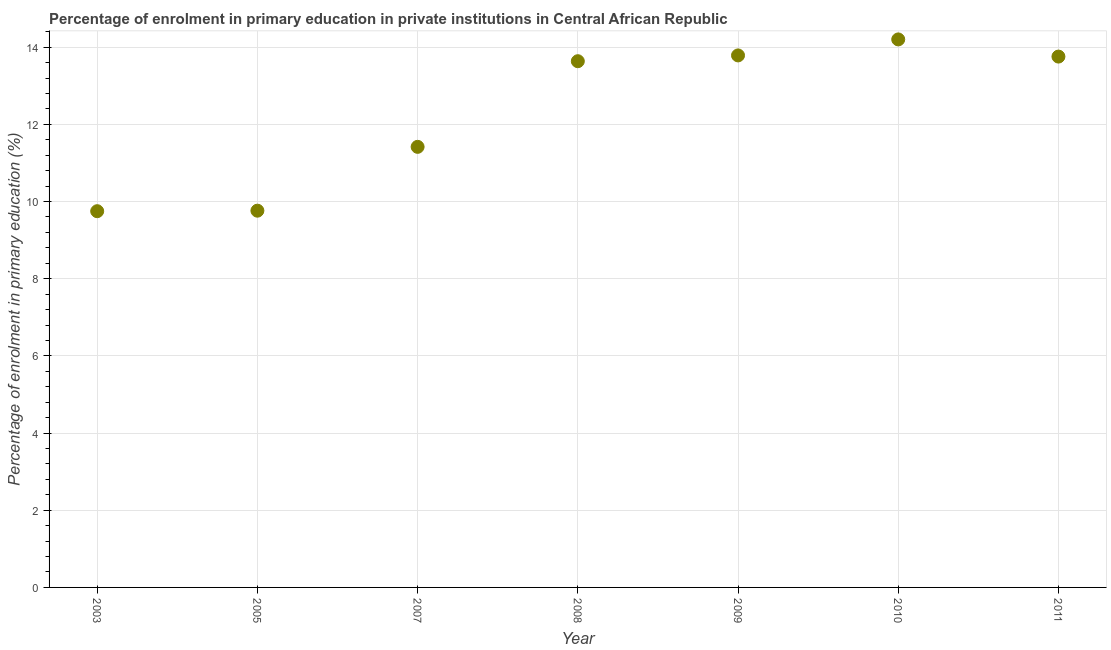What is the enrolment percentage in primary education in 2003?
Your answer should be very brief. 9.75. Across all years, what is the maximum enrolment percentage in primary education?
Provide a short and direct response. 14.2. Across all years, what is the minimum enrolment percentage in primary education?
Keep it short and to the point. 9.75. In which year was the enrolment percentage in primary education minimum?
Your response must be concise. 2003. What is the sum of the enrolment percentage in primary education?
Ensure brevity in your answer.  86.31. What is the difference between the enrolment percentage in primary education in 2010 and 2011?
Provide a short and direct response. 0.44. What is the average enrolment percentage in primary education per year?
Offer a terse response. 12.33. What is the median enrolment percentage in primary education?
Provide a short and direct response. 13.64. In how many years, is the enrolment percentage in primary education greater than 0.4 %?
Give a very brief answer. 7. What is the ratio of the enrolment percentage in primary education in 2008 to that in 2011?
Make the answer very short. 0.99. Is the difference between the enrolment percentage in primary education in 2005 and 2010 greater than the difference between any two years?
Your answer should be very brief. No. What is the difference between the highest and the second highest enrolment percentage in primary education?
Give a very brief answer. 0.41. What is the difference between the highest and the lowest enrolment percentage in primary education?
Provide a short and direct response. 4.45. In how many years, is the enrolment percentage in primary education greater than the average enrolment percentage in primary education taken over all years?
Provide a short and direct response. 4. How many years are there in the graph?
Make the answer very short. 7. Does the graph contain grids?
Your response must be concise. Yes. What is the title of the graph?
Provide a succinct answer. Percentage of enrolment in primary education in private institutions in Central African Republic. What is the label or title of the Y-axis?
Give a very brief answer. Percentage of enrolment in primary education (%). What is the Percentage of enrolment in primary education (%) in 2003?
Make the answer very short. 9.75. What is the Percentage of enrolment in primary education (%) in 2005?
Provide a short and direct response. 9.76. What is the Percentage of enrolment in primary education (%) in 2007?
Make the answer very short. 11.42. What is the Percentage of enrolment in primary education (%) in 2008?
Your answer should be compact. 13.64. What is the Percentage of enrolment in primary education (%) in 2009?
Provide a short and direct response. 13.79. What is the Percentage of enrolment in primary education (%) in 2010?
Provide a short and direct response. 14.2. What is the Percentage of enrolment in primary education (%) in 2011?
Keep it short and to the point. 13.76. What is the difference between the Percentage of enrolment in primary education (%) in 2003 and 2005?
Keep it short and to the point. -0.01. What is the difference between the Percentage of enrolment in primary education (%) in 2003 and 2007?
Ensure brevity in your answer.  -1.67. What is the difference between the Percentage of enrolment in primary education (%) in 2003 and 2008?
Your answer should be very brief. -3.89. What is the difference between the Percentage of enrolment in primary education (%) in 2003 and 2009?
Give a very brief answer. -4.04. What is the difference between the Percentage of enrolment in primary education (%) in 2003 and 2010?
Your answer should be very brief. -4.45. What is the difference between the Percentage of enrolment in primary education (%) in 2003 and 2011?
Make the answer very short. -4.01. What is the difference between the Percentage of enrolment in primary education (%) in 2005 and 2007?
Your answer should be compact. -1.65. What is the difference between the Percentage of enrolment in primary education (%) in 2005 and 2008?
Offer a very short reply. -3.87. What is the difference between the Percentage of enrolment in primary education (%) in 2005 and 2009?
Keep it short and to the point. -4.02. What is the difference between the Percentage of enrolment in primary education (%) in 2005 and 2010?
Offer a very short reply. -4.44. What is the difference between the Percentage of enrolment in primary education (%) in 2005 and 2011?
Ensure brevity in your answer.  -3.99. What is the difference between the Percentage of enrolment in primary education (%) in 2007 and 2008?
Offer a very short reply. -2.22. What is the difference between the Percentage of enrolment in primary education (%) in 2007 and 2009?
Make the answer very short. -2.37. What is the difference between the Percentage of enrolment in primary education (%) in 2007 and 2010?
Offer a terse response. -2.78. What is the difference between the Percentage of enrolment in primary education (%) in 2007 and 2011?
Give a very brief answer. -2.34. What is the difference between the Percentage of enrolment in primary education (%) in 2008 and 2009?
Give a very brief answer. -0.15. What is the difference between the Percentage of enrolment in primary education (%) in 2008 and 2010?
Provide a succinct answer. -0.56. What is the difference between the Percentage of enrolment in primary education (%) in 2008 and 2011?
Give a very brief answer. -0.12. What is the difference between the Percentage of enrolment in primary education (%) in 2009 and 2010?
Your answer should be compact. -0.41. What is the difference between the Percentage of enrolment in primary education (%) in 2009 and 2011?
Offer a very short reply. 0.03. What is the difference between the Percentage of enrolment in primary education (%) in 2010 and 2011?
Keep it short and to the point. 0.44. What is the ratio of the Percentage of enrolment in primary education (%) in 2003 to that in 2007?
Your answer should be compact. 0.85. What is the ratio of the Percentage of enrolment in primary education (%) in 2003 to that in 2008?
Give a very brief answer. 0.71. What is the ratio of the Percentage of enrolment in primary education (%) in 2003 to that in 2009?
Make the answer very short. 0.71. What is the ratio of the Percentage of enrolment in primary education (%) in 2003 to that in 2010?
Make the answer very short. 0.69. What is the ratio of the Percentage of enrolment in primary education (%) in 2003 to that in 2011?
Your response must be concise. 0.71. What is the ratio of the Percentage of enrolment in primary education (%) in 2005 to that in 2007?
Give a very brief answer. 0.85. What is the ratio of the Percentage of enrolment in primary education (%) in 2005 to that in 2008?
Your answer should be compact. 0.72. What is the ratio of the Percentage of enrolment in primary education (%) in 2005 to that in 2009?
Offer a very short reply. 0.71. What is the ratio of the Percentage of enrolment in primary education (%) in 2005 to that in 2010?
Provide a succinct answer. 0.69. What is the ratio of the Percentage of enrolment in primary education (%) in 2005 to that in 2011?
Make the answer very short. 0.71. What is the ratio of the Percentage of enrolment in primary education (%) in 2007 to that in 2008?
Your answer should be compact. 0.84. What is the ratio of the Percentage of enrolment in primary education (%) in 2007 to that in 2009?
Ensure brevity in your answer.  0.83. What is the ratio of the Percentage of enrolment in primary education (%) in 2007 to that in 2010?
Give a very brief answer. 0.8. What is the ratio of the Percentage of enrolment in primary education (%) in 2007 to that in 2011?
Give a very brief answer. 0.83. What is the ratio of the Percentage of enrolment in primary education (%) in 2008 to that in 2010?
Offer a very short reply. 0.96. What is the ratio of the Percentage of enrolment in primary education (%) in 2009 to that in 2011?
Give a very brief answer. 1. What is the ratio of the Percentage of enrolment in primary education (%) in 2010 to that in 2011?
Make the answer very short. 1.03. 